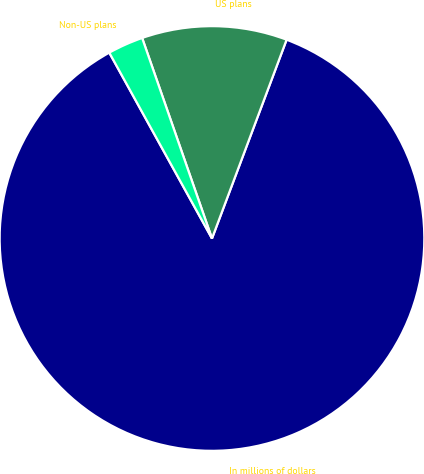<chart> <loc_0><loc_0><loc_500><loc_500><pie_chart><fcel>In millions of dollars<fcel>US plans<fcel>Non-US plans<nl><fcel>86.25%<fcel>11.05%<fcel>2.7%<nl></chart> 